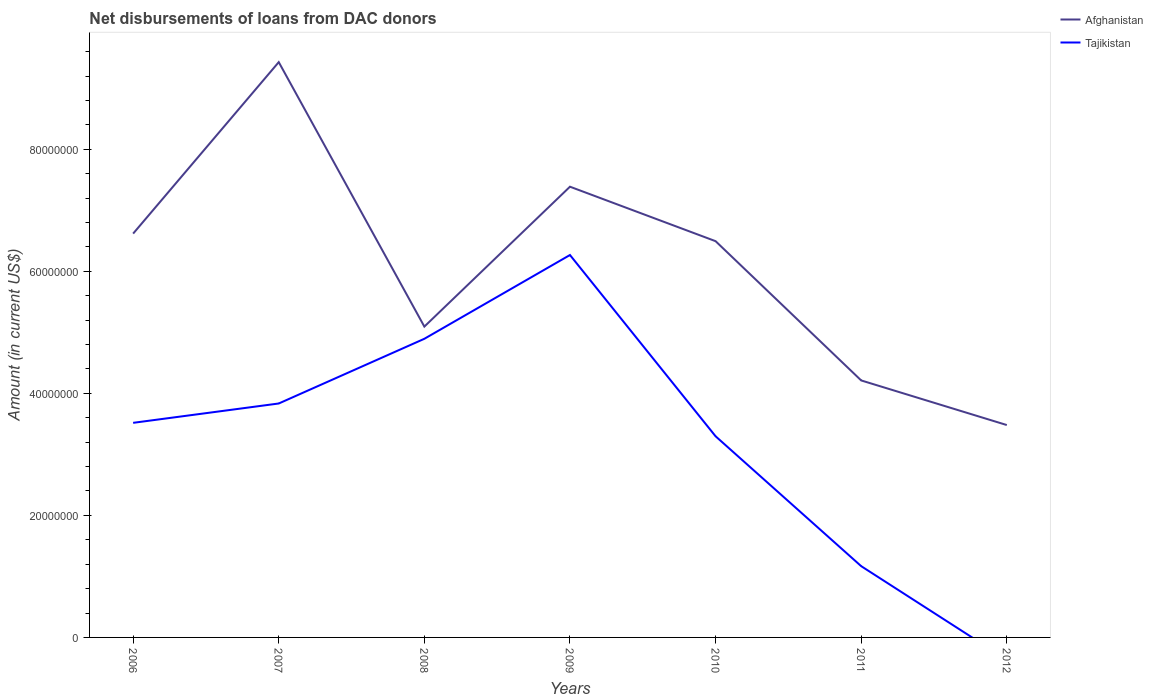Does the line corresponding to Tajikistan intersect with the line corresponding to Afghanistan?
Offer a terse response. No. Across all years, what is the maximum amount of loans disbursed in Tajikistan?
Provide a short and direct response. 0. What is the total amount of loans disbursed in Afghanistan in the graph?
Offer a terse response. 5.95e+07. What is the difference between the highest and the second highest amount of loans disbursed in Afghanistan?
Your answer should be very brief. 5.95e+07. What is the difference between the highest and the lowest amount of loans disbursed in Afghanistan?
Provide a short and direct response. 4. Is the amount of loans disbursed in Afghanistan strictly greater than the amount of loans disbursed in Tajikistan over the years?
Offer a very short reply. No. How many years are there in the graph?
Provide a succinct answer. 7. What is the difference between two consecutive major ticks on the Y-axis?
Offer a terse response. 2.00e+07. Does the graph contain any zero values?
Ensure brevity in your answer.  Yes. Does the graph contain grids?
Your answer should be very brief. No. How are the legend labels stacked?
Your response must be concise. Vertical. What is the title of the graph?
Your answer should be compact. Net disbursements of loans from DAC donors. What is the Amount (in current US$) in Afghanistan in 2006?
Make the answer very short. 6.62e+07. What is the Amount (in current US$) in Tajikistan in 2006?
Give a very brief answer. 3.52e+07. What is the Amount (in current US$) in Afghanistan in 2007?
Provide a succinct answer. 9.43e+07. What is the Amount (in current US$) of Tajikistan in 2007?
Your answer should be compact. 3.83e+07. What is the Amount (in current US$) in Afghanistan in 2008?
Keep it short and to the point. 5.09e+07. What is the Amount (in current US$) in Tajikistan in 2008?
Keep it short and to the point. 4.89e+07. What is the Amount (in current US$) in Afghanistan in 2009?
Offer a terse response. 7.39e+07. What is the Amount (in current US$) of Tajikistan in 2009?
Offer a terse response. 6.27e+07. What is the Amount (in current US$) of Afghanistan in 2010?
Your response must be concise. 6.49e+07. What is the Amount (in current US$) in Tajikistan in 2010?
Provide a short and direct response. 3.30e+07. What is the Amount (in current US$) in Afghanistan in 2011?
Keep it short and to the point. 4.21e+07. What is the Amount (in current US$) in Tajikistan in 2011?
Your response must be concise. 1.17e+07. What is the Amount (in current US$) in Afghanistan in 2012?
Keep it short and to the point. 3.48e+07. What is the Amount (in current US$) of Tajikistan in 2012?
Offer a very short reply. 0. Across all years, what is the maximum Amount (in current US$) of Afghanistan?
Provide a succinct answer. 9.43e+07. Across all years, what is the maximum Amount (in current US$) in Tajikistan?
Your answer should be compact. 6.27e+07. Across all years, what is the minimum Amount (in current US$) in Afghanistan?
Offer a very short reply. 3.48e+07. What is the total Amount (in current US$) of Afghanistan in the graph?
Offer a terse response. 4.27e+08. What is the total Amount (in current US$) in Tajikistan in the graph?
Keep it short and to the point. 2.30e+08. What is the difference between the Amount (in current US$) in Afghanistan in 2006 and that in 2007?
Your response must be concise. -2.81e+07. What is the difference between the Amount (in current US$) of Tajikistan in 2006 and that in 2007?
Give a very brief answer. -3.17e+06. What is the difference between the Amount (in current US$) in Afghanistan in 2006 and that in 2008?
Offer a very short reply. 1.52e+07. What is the difference between the Amount (in current US$) of Tajikistan in 2006 and that in 2008?
Ensure brevity in your answer.  -1.38e+07. What is the difference between the Amount (in current US$) in Afghanistan in 2006 and that in 2009?
Give a very brief answer. -7.69e+06. What is the difference between the Amount (in current US$) in Tajikistan in 2006 and that in 2009?
Keep it short and to the point. -2.75e+07. What is the difference between the Amount (in current US$) of Afghanistan in 2006 and that in 2010?
Your answer should be very brief. 1.24e+06. What is the difference between the Amount (in current US$) of Tajikistan in 2006 and that in 2010?
Provide a succinct answer. 2.20e+06. What is the difference between the Amount (in current US$) in Afghanistan in 2006 and that in 2011?
Make the answer very short. 2.41e+07. What is the difference between the Amount (in current US$) in Tajikistan in 2006 and that in 2011?
Give a very brief answer. 2.35e+07. What is the difference between the Amount (in current US$) in Afghanistan in 2006 and that in 2012?
Your answer should be compact. 3.14e+07. What is the difference between the Amount (in current US$) of Afghanistan in 2007 and that in 2008?
Your answer should be compact. 4.33e+07. What is the difference between the Amount (in current US$) in Tajikistan in 2007 and that in 2008?
Provide a succinct answer. -1.06e+07. What is the difference between the Amount (in current US$) of Afghanistan in 2007 and that in 2009?
Your response must be concise. 2.04e+07. What is the difference between the Amount (in current US$) in Tajikistan in 2007 and that in 2009?
Keep it short and to the point. -2.43e+07. What is the difference between the Amount (in current US$) of Afghanistan in 2007 and that in 2010?
Provide a succinct answer. 2.93e+07. What is the difference between the Amount (in current US$) of Tajikistan in 2007 and that in 2010?
Offer a very short reply. 5.37e+06. What is the difference between the Amount (in current US$) of Afghanistan in 2007 and that in 2011?
Keep it short and to the point. 5.22e+07. What is the difference between the Amount (in current US$) in Tajikistan in 2007 and that in 2011?
Your response must be concise. 2.67e+07. What is the difference between the Amount (in current US$) in Afghanistan in 2007 and that in 2012?
Your answer should be compact. 5.95e+07. What is the difference between the Amount (in current US$) in Afghanistan in 2008 and that in 2009?
Offer a terse response. -2.29e+07. What is the difference between the Amount (in current US$) in Tajikistan in 2008 and that in 2009?
Your answer should be compact. -1.37e+07. What is the difference between the Amount (in current US$) in Afghanistan in 2008 and that in 2010?
Offer a terse response. -1.40e+07. What is the difference between the Amount (in current US$) in Tajikistan in 2008 and that in 2010?
Offer a very short reply. 1.60e+07. What is the difference between the Amount (in current US$) in Afghanistan in 2008 and that in 2011?
Your answer should be compact. 8.82e+06. What is the difference between the Amount (in current US$) of Tajikistan in 2008 and that in 2011?
Make the answer very short. 3.73e+07. What is the difference between the Amount (in current US$) in Afghanistan in 2008 and that in 2012?
Ensure brevity in your answer.  1.61e+07. What is the difference between the Amount (in current US$) in Afghanistan in 2009 and that in 2010?
Provide a succinct answer. 8.93e+06. What is the difference between the Amount (in current US$) in Tajikistan in 2009 and that in 2010?
Keep it short and to the point. 2.97e+07. What is the difference between the Amount (in current US$) of Afghanistan in 2009 and that in 2011?
Make the answer very short. 3.17e+07. What is the difference between the Amount (in current US$) in Tajikistan in 2009 and that in 2011?
Your response must be concise. 5.10e+07. What is the difference between the Amount (in current US$) of Afghanistan in 2009 and that in 2012?
Give a very brief answer. 3.91e+07. What is the difference between the Amount (in current US$) of Afghanistan in 2010 and that in 2011?
Your answer should be very brief. 2.28e+07. What is the difference between the Amount (in current US$) in Tajikistan in 2010 and that in 2011?
Your response must be concise. 2.13e+07. What is the difference between the Amount (in current US$) in Afghanistan in 2010 and that in 2012?
Offer a very short reply. 3.01e+07. What is the difference between the Amount (in current US$) in Afghanistan in 2011 and that in 2012?
Provide a short and direct response. 7.31e+06. What is the difference between the Amount (in current US$) of Afghanistan in 2006 and the Amount (in current US$) of Tajikistan in 2007?
Your answer should be very brief. 2.78e+07. What is the difference between the Amount (in current US$) of Afghanistan in 2006 and the Amount (in current US$) of Tajikistan in 2008?
Keep it short and to the point. 1.72e+07. What is the difference between the Amount (in current US$) in Afghanistan in 2006 and the Amount (in current US$) in Tajikistan in 2009?
Offer a terse response. 3.51e+06. What is the difference between the Amount (in current US$) in Afghanistan in 2006 and the Amount (in current US$) in Tajikistan in 2010?
Your answer should be very brief. 3.32e+07. What is the difference between the Amount (in current US$) in Afghanistan in 2006 and the Amount (in current US$) in Tajikistan in 2011?
Keep it short and to the point. 5.45e+07. What is the difference between the Amount (in current US$) in Afghanistan in 2007 and the Amount (in current US$) in Tajikistan in 2008?
Ensure brevity in your answer.  4.53e+07. What is the difference between the Amount (in current US$) of Afghanistan in 2007 and the Amount (in current US$) of Tajikistan in 2009?
Your answer should be very brief. 3.16e+07. What is the difference between the Amount (in current US$) of Afghanistan in 2007 and the Amount (in current US$) of Tajikistan in 2010?
Keep it short and to the point. 6.13e+07. What is the difference between the Amount (in current US$) of Afghanistan in 2007 and the Amount (in current US$) of Tajikistan in 2011?
Your response must be concise. 8.26e+07. What is the difference between the Amount (in current US$) of Afghanistan in 2008 and the Amount (in current US$) of Tajikistan in 2009?
Offer a very short reply. -1.17e+07. What is the difference between the Amount (in current US$) in Afghanistan in 2008 and the Amount (in current US$) in Tajikistan in 2010?
Make the answer very short. 1.80e+07. What is the difference between the Amount (in current US$) in Afghanistan in 2008 and the Amount (in current US$) in Tajikistan in 2011?
Provide a short and direct response. 3.93e+07. What is the difference between the Amount (in current US$) in Afghanistan in 2009 and the Amount (in current US$) in Tajikistan in 2010?
Give a very brief answer. 4.09e+07. What is the difference between the Amount (in current US$) in Afghanistan in 2009 and the Amount (in current US$) in Tajikistan in 2011?
Keep it short and to the point. 6.22e+07. What is the difference between the Amount (in current US$) in Afghanistan in 2010 and the Amount (in current US$) in Tajikistan in 2011?
Provide a short and direct response. 5.33e+07. What is the average Amount (in current US$) of Afghanistan per year?
Make the answer very short. 6.10e+07. What is the average Amount (in current US$) of Tajikistan per year?
Your response must be concise. 3.28e+07. In the year 2006, what is the difference between the Amount (in current US$) in Afghanistan and Amount (in current US$) in Tajikistan?
Ensure brevity in your answer.  3.10e+07. In the year 2007, what is the difference between the Amount (in current US$) in Afghanistan and Amount (in current US$) in Tajikistan?
Give a very brief answer. 5.59e+07. In the year 2009, what is the difference between the Amount (in current US$) in Afghanistan and Amount (in current US$) in Tajikistan?
Your response must be concise. 1.12e+07. In the year 2010, what is the difference between the Amount (in current US$) of Afghanistan and Amount (in current US$) of Tajikistan?
Your answer should be very brief. 3.20e+07. In the year 2011, what is the difference between the Amount (in current US$) of Afghanistan and Amount (in current US$) of Tajikistan?
Give a very brief answer. 3.04e+07. What is the ratio of the Amount (in current US$) of Afghanistan in 2006 to that in 2007?
Offer a very short reply. 0.7. What is the ratio of the Amount (in current US$) of Tajikistan in 2006 to that in 2007?
Your answer should be very brief. 0.92. What is the ratio of the Amount (in current US$) of Afghanistan in 2006 to that in 2008?
Give a very brief answer. 1.3. What is the ratio of the Amount (in current US$) of Tajikistan in 2006 to that in 2008?
Give a very brief answer. 0.72. What is the ratio of the Amount (in current US$) in Afghanistan in 2006 to that in 2009?
Your answer should be compact. 0.9. What is the ratio of the Amount (in current US$) in Tajikistan in 2006 to that in 2009?
Your response must be concise. 0.56. What is the ratio of the Amount (in current US$) in Afghanistan in 2006 to that in 2010?
Your answer should be compact. 1.02. What is the ratio of the Amount (in current US$) of Tajikistan in 2006 to that in 2010?
Offer a terse response. 1.07. What is the ratio of the Amount (in current US$) in Afghanistan in 2006 to that in 2011?
Keep it short and to the point. 1.57. What is the ratio of the Amount (in current US$) in Tajikistan in 2006 to that in 2011?
Give a very brief answer. 3.01. What is the ratio of the Amount (in current US$) of Afghanistan in 2006 to that in 2012?
Make the answer very short. 1.9. What is the ratio of the Amount (in current US$) of Afghanistan in 2007 to that in 2008?
Offer a terse response. 1.85. What is the ratio of the Amount (in current US$) of Tajikistan in 2007 to that in 2008?
Provide a succinct answer. 0.78. What is the ratio of the Amount (in current US$) of Afghanistan in 2007 to that in 2009?
Keep it short and to the point. 1.28. What is the ratio of the Amount (in current US$) in Tajikistan in 2007 to that in 2009?
Offer a terse response. 0.61. What is the ratio of the Amount (in current US$) in Afghanistan in 2007 to that in 2010?
Your response must be concise. 1.45. What is the ratio of the Amount (in current US$) in Tajikistan in 2007 to that in 2010?
Ensure brevity in your answer.  1.16. What is the ratio of the Amount (in current US$) of Afghanistan in 2007 to that in 2011?
Your answer should be very brief. 2.24. What is the ratio of the Amount (in current US$) in Tajikistan in 2007 to that in 2011?
Your response must be concise. 3.28. What is the ratio of the Amount (in current US$) of Afghanistan in 2007 to that in 2012?
Your answer should be compact. 2.71. What is the ratio of the Amount (in current US$) of Afghanistan in 2008 to that in 2009?
Offer a terse response. 0.69. What is the ratio of the Amount (in current US$) of Tajikistan in 2008 to that in 2009?
Give a very brief answer. 0.78. What is the ratio of the Amount (in current US$) of Afghanistan in 2008 to that in 2010?
Offer a very short reply. 0.78. What is the ratio of the Amount (in current US$) in Tajikistan in 2008 to that in 2010?
Offer a terse response. 1.48. What is the ratio of the Amount (in current US$) of Afghanistan in 2008 to that in 2011?
Offer a very short reply. 1.21. What is the ratio of the Amount (in current US$) of Tajikistan in 2008 to that in 2011?
Provide a short and direct response. 4.19. What is the ratio of the Amount (in current US$) in Afghanistan in 2008 to that in 2012?
Keep it short and to the point. 1.46. What is the ratio of the Amount (in current US$) in Afghanistan in 2009 to that in 2010?
Ensure brevity in your answer.  1.14. What is the ratio of the Amount (in current US$) in Tajikistan in 2009 to that in 2010?
Provide a short and direct response. 1.9. What is the ratio of the Amount (in current US$) in Afghanistan in 2009 to that in 2011?
Offer a very short reply. 1.75. What is the ratio of the Amount (in current US$) in Tajikistan in 2009 to that in 2011?
Your answer should be very brief. 5.37. What is the ratio of the Amount (in current US$) in Afghanistan in 2009 to that in 2012?
Provide a short and direct response. 2.12. What is the ratio of the Amount (in current US$) in Afghanistan in 2010 to that in 2011?
Your answer should be compact. 1.54. What is the ratio of the Amount (in current US$) of Tajikistan in 2010 to that in 2011?
Your answer should be very brief. 2.82. What is the ratio of the Amount (in current US$) in Afghanistan in 2010 to that in 2012?
Offer a very short reply. 1.87. What is the ratio of the Amount (in current US$) of Afghanistan in 2011 to that in 2012?
Provide a short and direct response. 1.21. What is the difference between the highest and the second highest Amount (in current US$) of Afghanistan?
Your response must be concise. 2.04e+07. What is the difference between the highest and the second highest Amount (in current US$) in Tajikistan?
Provide a succinct answer. 1.37e+07. What is the difference between the highest and the lowest Amount (in current US$) of Afghanistan?
Your answer should be very brief. 5.95e+07. What is the difference between the highest and the lowest Amount (in current US$) in Tajikistan?
Provide a succinct answer. 6.27e+07. 